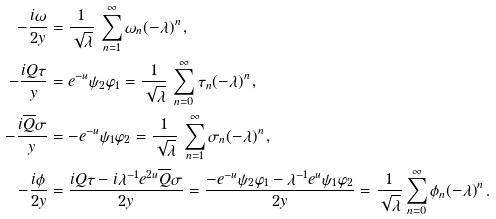<formula> <loc_0><loc_0><loc_500><loc_500>- \frac { i \omega } { 2 y } & = \frac { 1 } { \sqrt { \lambda } } \, \sum _ { n = 1 } ^ { \infty } \omega _ { n } ( - \lambda ) ^ { n } \, , \\ - \frac { i Q \tau } { y } & = e ^ { - u } \psi _ { 2 } \varphi _ { 1 } = \frac { 1 } { \sqrt { \lambda } } \, \sum _ { n = 0 } ^ { \infty } \tau _ { n } ( - \lambda ) ^ { n } \, , \\ - \frac { i \overline { Q } \sigma } { y } & = - e ^ { - u } \psi _ { 1 } \varphi _ { 2 } = \frac { 1 } { \sqrt { \lambda } } \, \sum _ { n = 1 } ^ { \infty } \sigma _ { n } ( - \lambda ) ^ { n } \, , \\ - \frac { i \phi } { 2 y } & = \frac { i Q \tau - i \lambda ^ { - 1 } e ^ { 2 u } \overline { Q } \sigma } { 2 y } = \frac { - e ^ { - u } \psi _ { 2 } \varphi _ { 1 } - \lambda ^ { - 1 } e ^ { u } \psi _ { 1 } \varphi _ { 2 } } { 2 y } = \frac { 1 } { \sqrt { \lambda } } \sum _ { n = 0 } ^ { \infty } \phi _ { n } ( - \lambda ) ^ { n } \, .</formula> 